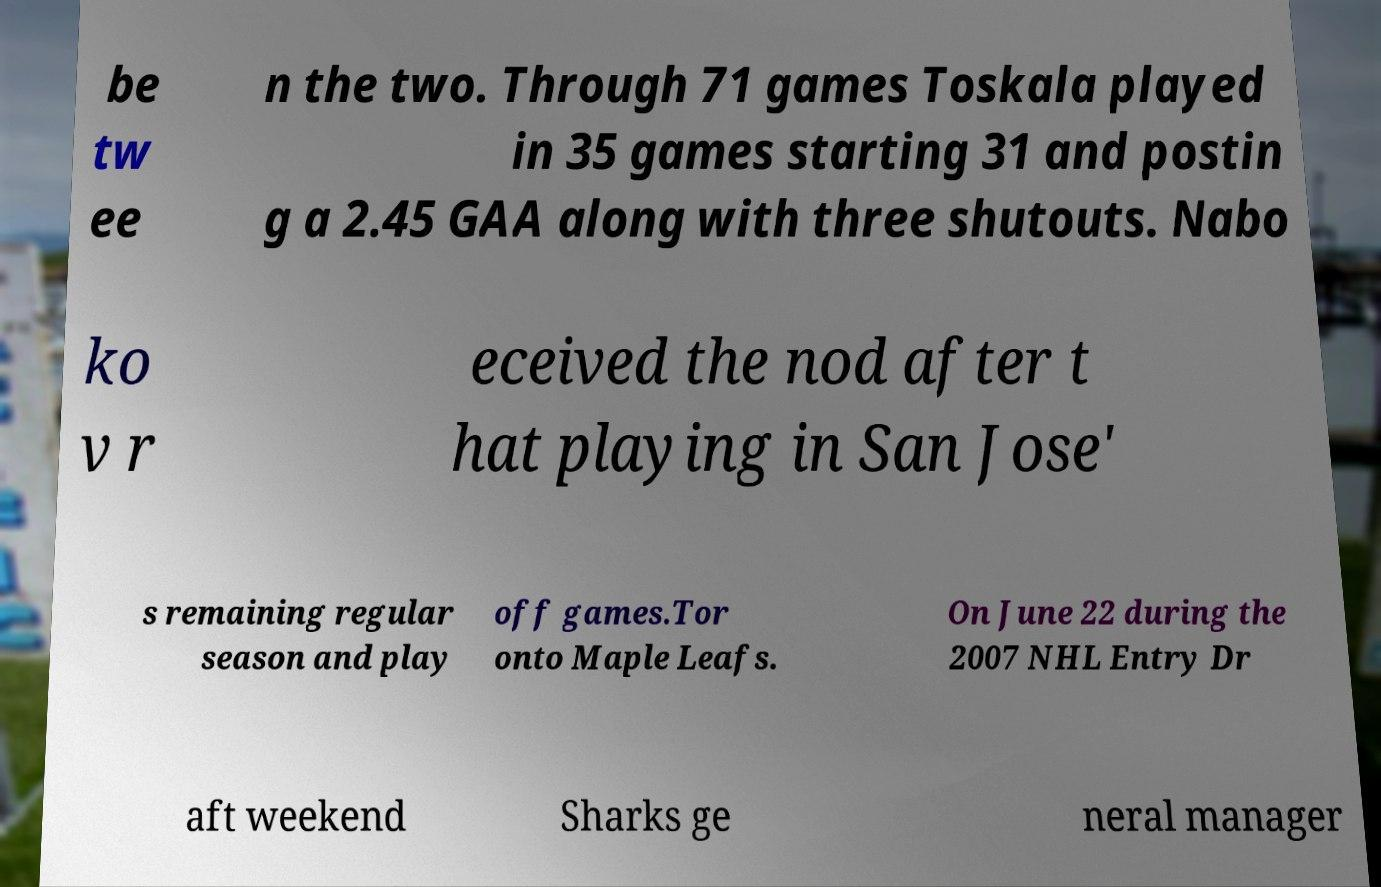Could you assist in decoding the text presented in this image and type it out clearly? be tw ee n the two. Through 71 games Toskala played in 35 games starting 31 and postin g a 2.45 GAA along with three shutouts. Nabo ko v r eceived the nod after t hat playing in San Jose' s remaining regular season and play off games.Tor onto Maple Leafs. On June 22 during the 2007 NHL Entry Dr aft weekend Sharks ge neral manager 